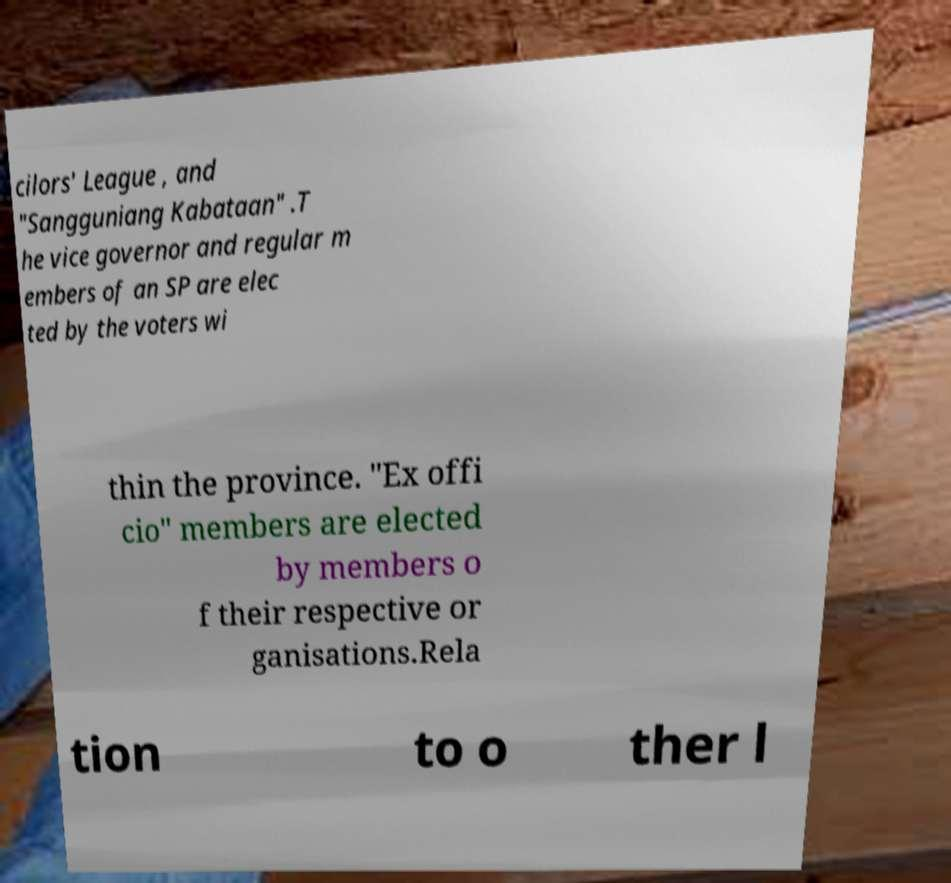There's text embedded in this image that I need extracted. Can you transcribe it verbatim? cilors' League , and "Sangguniang Kabataan" .T he vice governor and regular m embers of an SP are elec ted by the voters wi thin the province. "Ex offi cio" members are elected by members o f their respective or ganisations.Rela tion to o ther l 